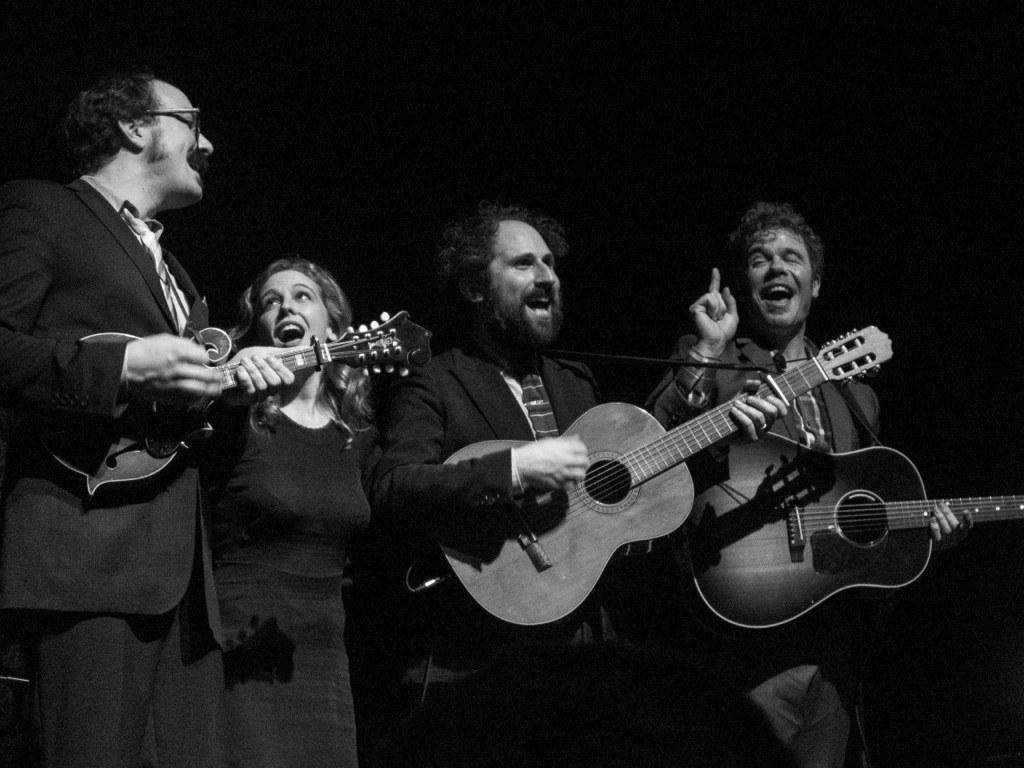What is the color scheme of the image? The image is black and white. How many people are in the image? There are four persons in the image. What are the persons doing in the image? The persons are standing and singing a song. How many of them are playing a guitar? Two persons are playing guitar in the image. What is the person holding in the image? One person is holding a music instrument. Can you see any railway tracks in the image? There are no railway tracks visible in the image. Is anyone wearing a veil in the image? There is no mention of a veil or any similar clothing item in the image. 